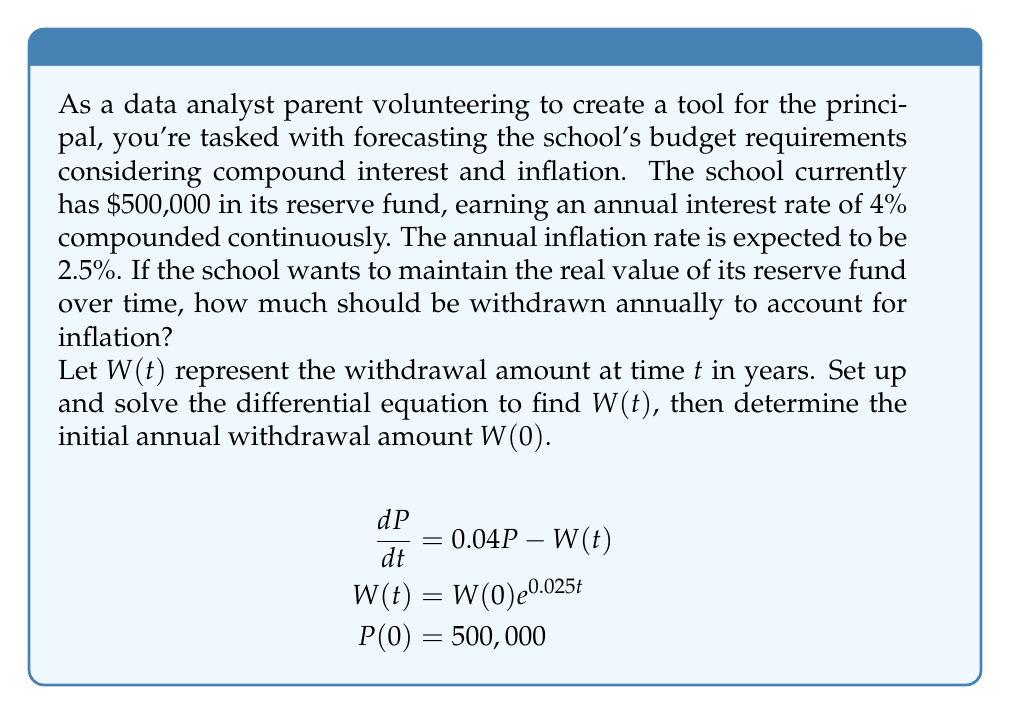What is the answer to this math problem? To solve this problem, we need to set up and solve a differential equation that accounts for the fund's growth and the withdrawals:

1) The differential equation for the principal $P$ is:
   $$\frac{dP}{dt} = 0.04P - W(t)$$

2) We know that $W(t) = W(0)e^{0.025t}$ to account for inflation.

3) Substituting this into our differential equation:
   $$\frac{dP}{dt} = 0.04P - W(0)e^{0.025t}$$

4) This is a linear first-order differential equation. The general solution is:
   $$P(t) = e^{0.04t}(C - W(0)\int e^{-0.015t}dt)$$

5) Solving the integral:
   $$P(t) = e^{0.04t}(C + \frac{W(0)}{0.015}e^{-0.015t})$$

6) Using the initial condition $P(0) = 500,000$:
   $$500,000 = C + \frac{W(0)}{0.015}$$

7) For the real value to remain constant, we need $P(t)$ to be constant:
   $$500,000 = e^{0.04t}(C + \frac{W(0)}{0.015}e^{-0.015t})$$

8) This is only possible if:
   $$C = -\frac{W(0)}{0.015}$$

9) Substituting this back into the equation from step 6:
   $$500,000 = -\frac{W(0)}{0.015} + \frac{W(0)}{0.015}$$
   $$500,000 = 0$$

10) This contradiction shows that it's impossible to keep the principal exactly constant. Instead, we can aim to keep it approximately constant by setting:
    $$W(0) = 500,000 * 0.015 = 7,500$$

This means the initial annual withdrawal should be $7,500, which will increase with inflation over time.
Answer: $W(0) = $7,500 